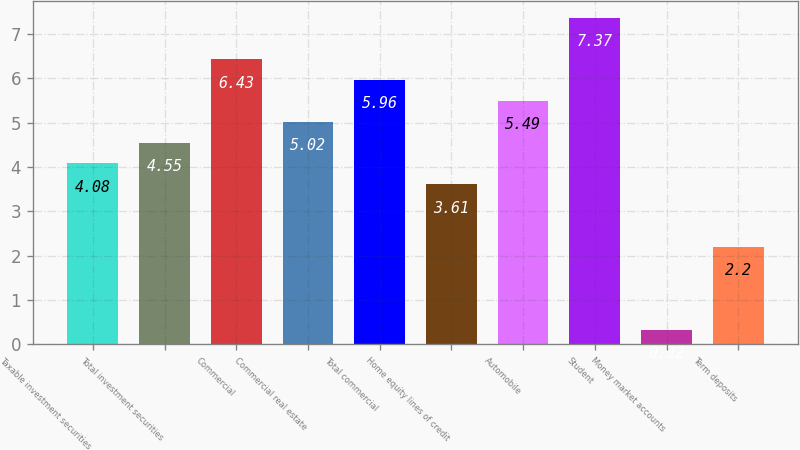Convert chart. <chart><loc_0><loc_0><loc_500><loc_500><bar_chart><fcel>Taxable investment securities<fcel>Total investment securities<fcel>Commercial<fcel>Commercial real estate<fcel>Total commercial<fcel>Home equity lines of credit<fcel>Automobile<fcel>Student<fcel>Money market accounts<fcel>Term deposits<nl><fcel>4.08<fcel>4.55<fcel>6.43<fcel>5.02<fcel>5.96<fcel>3.61<fcel>5.49<fcel>7.37<fcel>0.32<fcel>2.2<nl></chart> 